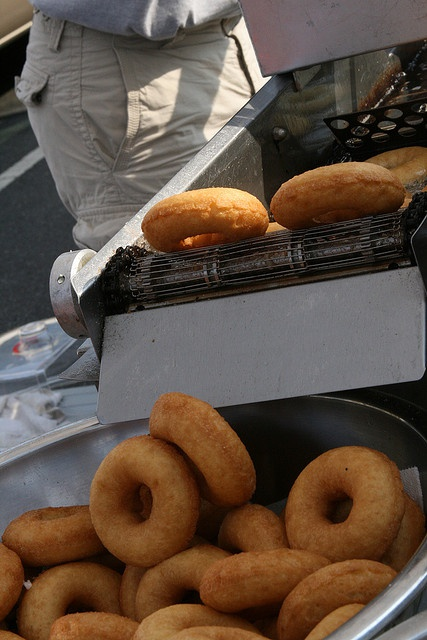Describe the objects in this image and their specific colors. I can see people in gray, darkgray, ivory, and black tones, donut in gray, maroon, black, and brown tones, donut in gray, maroon, brown, and black tones, donut in gray, brown, maroon, and black tones, and donut in gray, brown, maroon, and black tones in this image. 